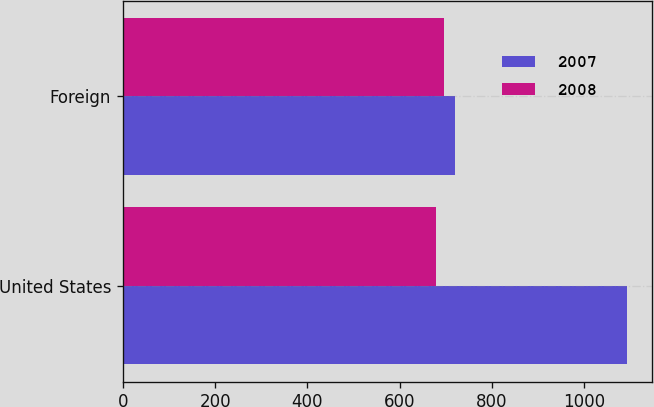Convert chart. <chart><loc_0><loc_0><loc_500><loc_500><stacked_bar_chart><ecel><fcel>United States<fcel>Foreign<nl><fcel>2007<fcel>1092<fcel>720<nl><fcel>2008<fcel>678<fcel>696<nl></chart> 